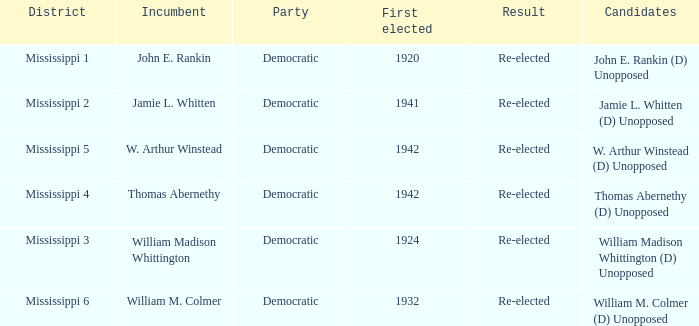What candidates are from mississippi 6? William M. Colmer (D) Unopposed. 